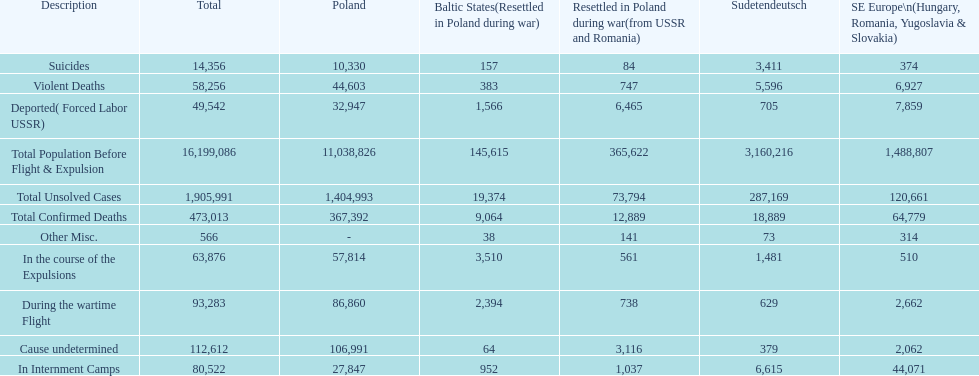What is the difference between suicides in poland and sudetendeutsch? 6919. 